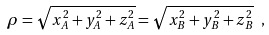Convert formula to latex. <formula><loc_0><loc_0><loc_500><loc_500>\rho = \sqrt { x ^ { 2 } _ { A } + y ^ { 2 } _ { A } + z ^ { 2 } _ { A } } = \sqrt { x ^ { 2 } _ { B } + y ^ { 2 } _ { B } + z ^ { 2 } _ { B } } \ ,</formula> 